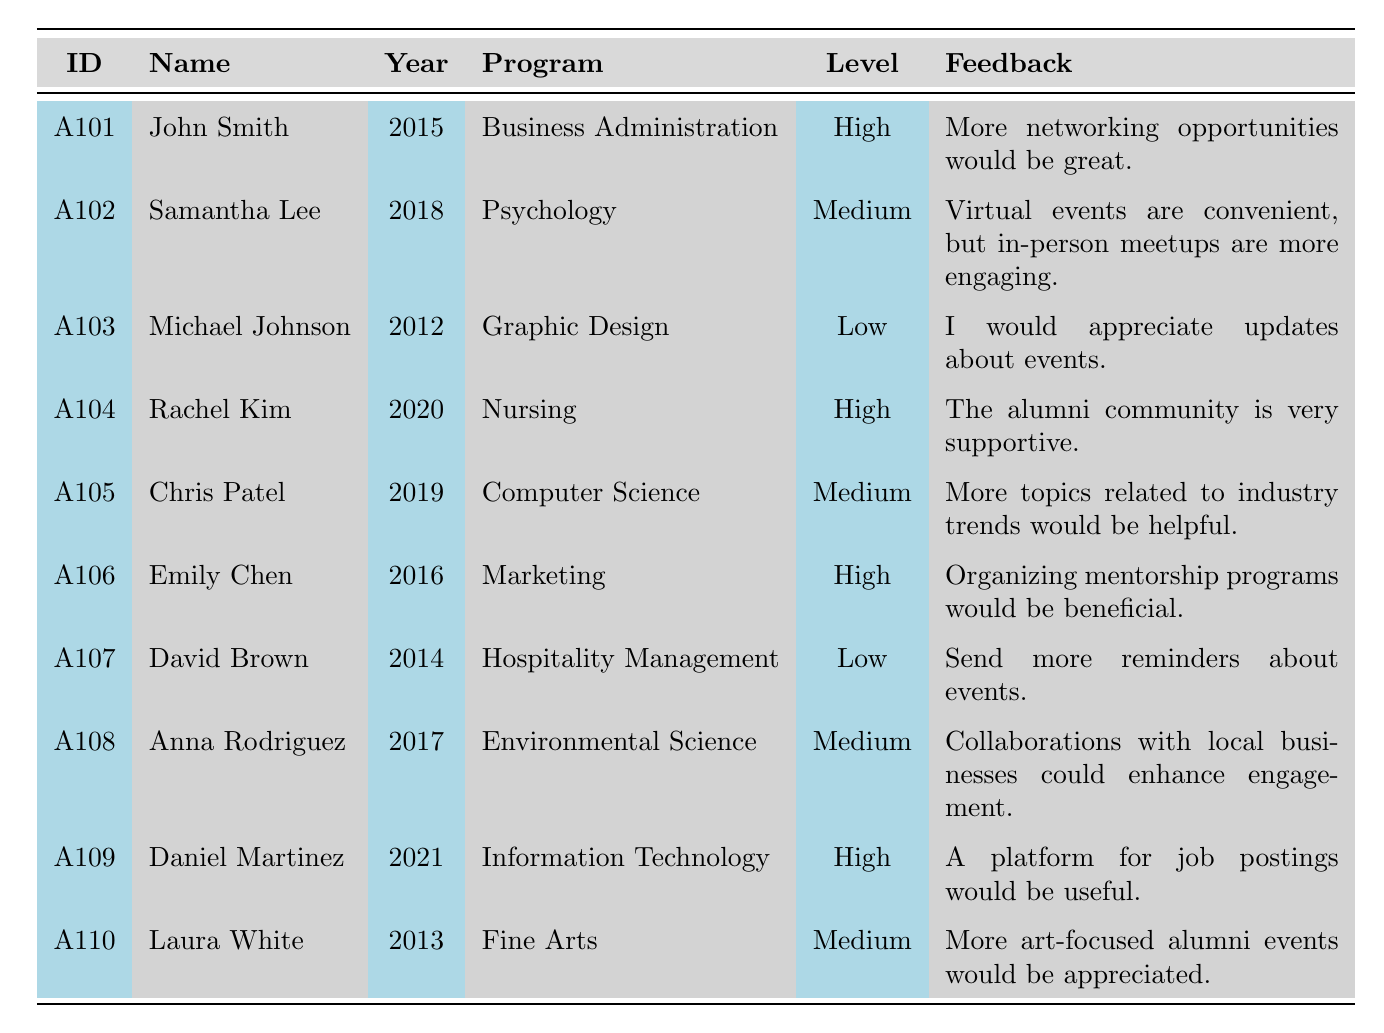What is the name of the alumnus who graduated in 2018? From the table, we look for the row where the graduation year is 2018. The alumni_id A102 corresponds to Samantha Lee.
Answer: Samantha Lee How many alumni have a high engagement level? The table lists alumni engagement levels. Counting the entries with "High" results in 4 individuals: John Smith, Rachel Kim, Emily Chen, and Daniel Martinez.
Answer: 4 What feedback did Daniel Martinez provide? By locating Daniel Martinez's row using the alumni_id A109, we see that his feedback is "A platform for job postings would be useful."
Answer: A platform for job postings would be useful Which program had the lowest engagement level? The table shows that both Michael Johnson (Graphic Design) and David Brown (Hospitality Management) have "Low" engagement levels, but we need to identify the program. The first one listed with low engagement is Graphic Design.
Answer: Graphic Design Is Emily Chen's engagement level higher than Samantha Lee's? Comparing their engagement levels, Emily Chen's is "High" and Samantha Lee's is "Medium," so Emily Chen's engagement level is indeed higher.
Answer: Yes What percentage of alumni provided feedback emphasizing the need for more events or opportunities? Counting the relevant feedback: John Smith, David Brown, and Emily Chen explicitly expressed a desire for more events or opportunities. That's 3 out of 10 alumni: (3/10)*100 = 30%.
Answer: 30% Which alumni's responses indicate a preference for virtual events? Checking the responses, Samantha Lee mentioned "Virtual events are convenient," indicating a preference for them.
Answer: Samantha Lee How many alumni have graduated after 2015? Inspecting the graduation years, the years after 2015 are 2016, 2017, 2018, 2019, and 2020. The corresponding alumni are Emily Chen, Anna Rodriguez, Chris Patel, Rachel Kim, and Daniel Martinez, totaling 6 alumni.
Answer: 6 What is the overall engagement level for the Nursing program? The entry for Rachel Kim under the Nursing program indicates a "High" engagement level. Therefore, the overall engagement level for this program is high.
Answer: High Which alumnus has the least engagement based on the survey response? Michael Johnson noted he hasn't participated in any activities recently. David Brown also stated he hasn't thought about activities lately. However, Michael Johnson's response is more definitive.
Answer: Michael Johnson 